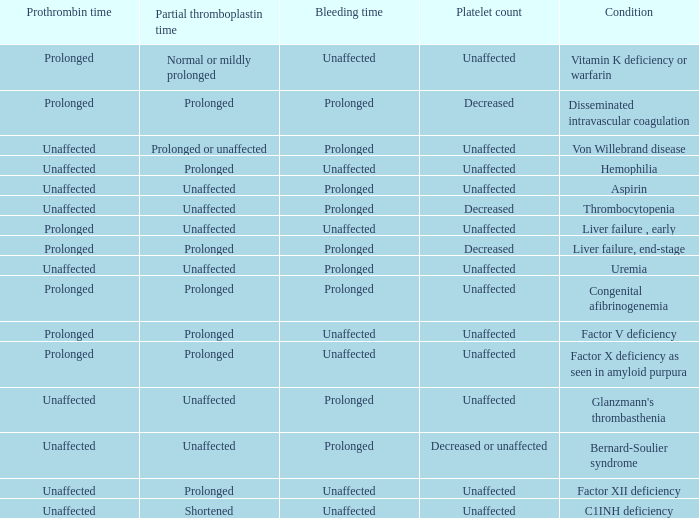Which Bleeding time has a Condition of factor x deficiency as seen in amyloid purpura? Unaffected. 